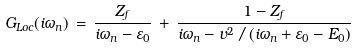<formula> <loc_0><loc_0><loc_500><loc_500>G _ { L o c } ( i \omega _ { n } ) \, = \, \frac { Z _ { f } } { i \omega _ { n } - \varepsilon _ { 0 } } \, + \, \frac { 1 - Z _ { f } } { i \omega _ { n } - v ^ { 2 } \, / \, ( i \omega _ { n } + \varepsilon _ { 0 } - E _ { 0 } ) }</formula> 